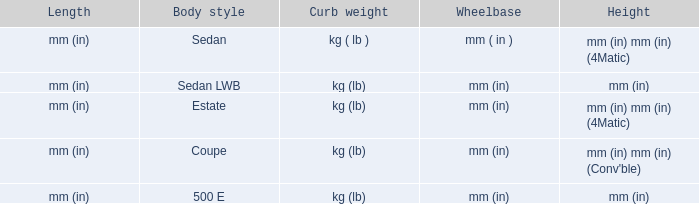Could you parse the entire table? {'header': ['Length', 'Body style', 'Curb weight', 'Wheelbase', 'Height'], 'rows': [['mm (in)', 'Sedan', 'kg ( lb )', 'mm ( in )', 'mm (in) mm (in) (4Matic)'], ['mm (in)', 'Sedan LWB', 'kg (lb)', 'mm (in)', 'mm (in)'], ['mm (in)', 'Estate', 'kg (lb)', 'mm (in)', 'mm (in) mm (in) (4Matic)'], ['mm (in)', 'Coupe', 'kg (lb)', 'mm (in)', "mm (in) mm (in) (Conv'ble)"], ['mm (in)', '500 E', 'kg (lb)', 'mm (in)', 'mm (in)']]} What's the length of the model with 500 E body style? Mm (in). 